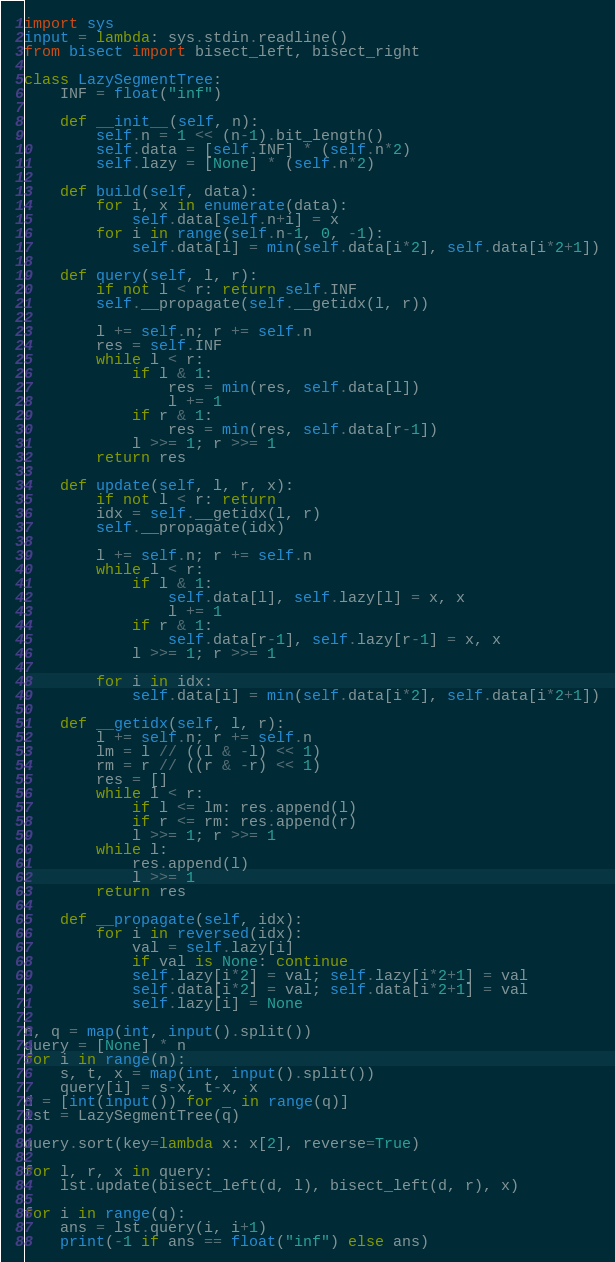<code> <loc_0><loc_0><loc_500><loc_500><_Python_>import sys
input = lambda: sys.stdin.readline()
from bisect import bisect_left, bisect_right

class LazySegmentTree:
    INF = float("inf")

    def __init__(self, n):
        self.n = 1 << (n-1).bit_length()
        self.data = [self.INF] * (self.n*2)
        self.lazy = [None] * (self.n*2)
    
    def build(self, data):
        for i, x in enumerate(data):
            self.data[self.n+i] = x
        for i in range(self.n-1, 0, -1):
            self.data[i] = min(self.data[i*2], self.data[i*2+1])
        
    def query(self, l, r):
        if not l < r: return self.INF
        self.__propagate(self.__getidx(l, r))

        l += self.n; r += self.n 
        res = self.INF
        while l < r:
            if l & 1:
                res = min(res, self.data[l])
                l += 1
            if r & 1:
                res = min(res, self.data[r-1])
            l >>= 1; r >>= 1
        return res
    
    def update(self, l, r, x):
        if not l < r: return
        idx = self.__getidx(l, r)
        self.__propagate(idx)

        l += self.n; r += self.n 
        while l < r:
            if l & 1:
                self.data[l], self.lazy[l] = x, x
                l += 1
            if r & 1:
                self.data[r-1], self.lazy[r-1] = x, x
            l >>= 1; r >>= 1
    
        for i in idx:
            self.data[i] = min(self.data[i*2], self.data[i*2+1])

    def __getidx(self, l, r):
        l += self.n; r += self.n 
        lm = l // ((l & -l) << 1)
        rm = r // ((r & -r) << 1)
        res = []
        while l < r:
            if l <= lm: res.append(l)
            if r <= rm: res.append(r)
            l >>= 1; r >>= 1
        while l:
            res.append(l)
            l >>= 1
        return res
    
    def __propagate(self, idx):
        for i in reversed(idx):
            val = self.lazy[i]
            if val is None: continue
            self.lazy[i*2] = val; self.lazy[i*2+1] = val
            self.data[i*2] = val; self.data[i*2+1] = val
            self.lazy[i] = None

n, q = map(int, input().split())
query = [None] * n
for i in range(n):
    s, t, x = map(int, input().split())
    query[i] = s-x, t-x, x
d = [int(input()) for _ in range(q)]
lst = LazySegmentTree(q)

query.sort(key=lambda x: x[2], reverse=True)

for l, r, x in query:
    lst.update(bisect_left(d, l), bisect_left(d, r), x)

for i in range(q):
    ans = lst.query(i, i+1)
    print(-1 if ans == float("inf") else ans)
</code> 